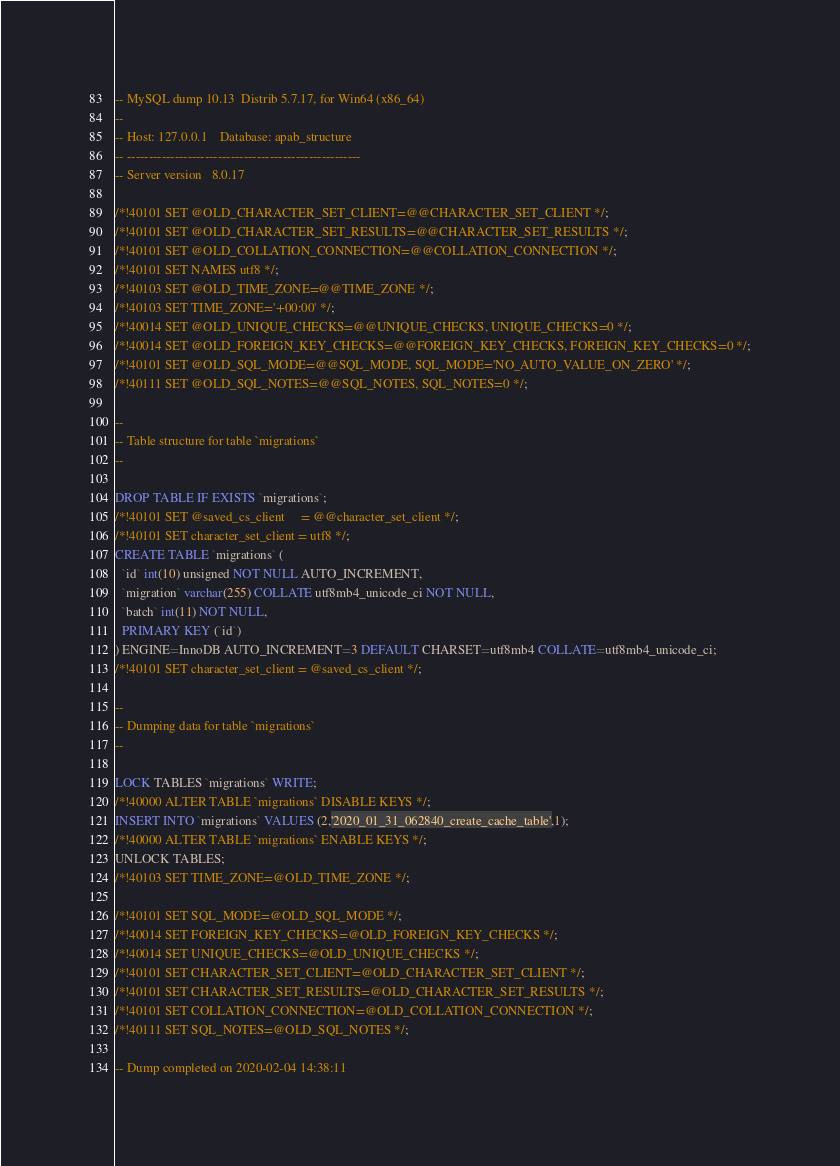<code> <loc_0><loc_0><loc_500><loc_500><_SQL_>-- MySQL dump 10.13  Distrib 5.7.17, for Win64 (x86_64)
--
-- Host: 127.0.0.1    Database: apab_structure
-- ------------------------------------------------------
-- Server version	8.0.17

/*!40101 SET @OLD_CHARACTER_SET_CLIENT=@@CHARACTER_SET_CLIENT */;
/*!40101 SET @OLD_CHARACTER_SET_RESULTS=@@CHARACTER_SET_RESULTS */;
/*!40101 SET @OLD_COLLATION_CONNECTION=@@COLLATION_CONNECTION */;
/*!40101 SET NAMES utf8 */;
/*!40103 SET @OLD_TIME_ZONE=@@TIME_ZONE */;
/*!40103 SET TIME_ZONE='+00:00' */;
/*!40014 SET @OLD_UNIQUE_CHECKS=@@UNIQUE_CHECKS, UNIQUE_CHECKS=0 */;
/*!40014 SET @OLD_FOREIGN_KEY_CHECKS=@@FOREIGN_KEY_CHECKS, FOREIGN_KEY_CHECKS=0 */;
/*!40101 SET @OLD_SQL_MODE=@@SQL_MODE, SQL_MODE='NO_AUTO_VALUE_ON_ZERO' */;
/*!40111 SET @OLD_SQL_NOTES=@@SQL_NOTES, SQL_NOTES=0 */;

--
-- Table structure for table `migrations`
--

DROP TABLE IF EXISTS `migrations`;
/*!40101 SET @saved_cs_client     = @@character_set_client */;
/*!40101 SET character_set_client = utf8 */;
CREATE TABLE `migrations` (
  `id` int(10) unsigned NOT NULL AUTO_INCREMENT,
  `migration` varchar(255) COLLATE utf8mb4_unicode_ci NOT NULL,
  `batch` int(11) NOT NULL,
  PRIMARY KEY (`id`)
) ENGINE=InnoDB AUTO_INCREMENT=3 DEFAULT CHARSET=utf8mb4 COLLATE=utf8mb4_unicode_ci;
/*!40101 SET character_set_client = @saved_cs_client */;

--
-- Dumping data for table `migrations`
--

LOCK TABLES `migrations` WRITE;
/*!40000 ALTER TABLE `migrations` DISABLE KEYS */;
INSERT INTO `migrations` VALUES (2,'2020_01_31_062840_create_cache_table',1);
/*!40000 ALTER TABLE `migrations` ENABLE KEYS */;
UNLOCK TABLES;
/*!40103 SET TIME_ZONE=@OLD_TIME_ZONE */;

/*!40101 SET SQL_MODE=@OLD_SQL_MODE */;
/*!40014 SET FOREIGN_KEY_CHECKS=@OLD_FOREIGN_KEY_CHECKS */;
/*!40014 SET UNIQUE_CHECKS=@OLD_UNIQUE_CHECKS */;
/*!40101 SET CHARACTER_SET_CLIENT=@OLD_CHARACTER_SET_CLIENT */;
/*!40101 SET CHARACTER_SET_RESULTS=@OLD_CHARACTER_SET_RESULTS */;
/*!40101 SET COLLATION_CONNECTION=@OLD_COLLATION_CONNECTION */;
/*!40111 SET SQL_NOTES=@OLD_SQL_NOTES */;

-- Dump completed on 2020-02-04 14:38:11
</code> 